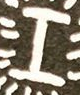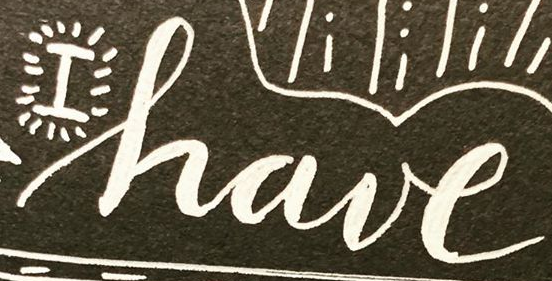What text is displayed in these images sequentially, separated by a semicolon? I; have 